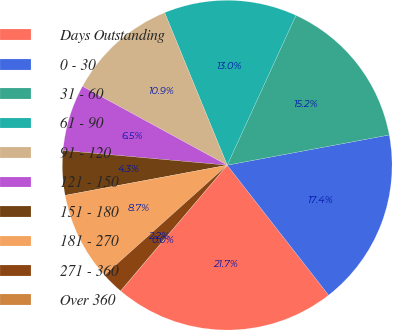Convert chart to OTSL. <chart><loc_0><loc_0><loc_500><loc_500><pie_chart><fcel>Days Outstanding<fcel>0 - 30<fcel>31 - 60<fcel>61 - 90<fcel>91 - 120<fcel>121 - 150<fcel>151 - 180<fcel>181 - 270<fcel>271 - 360<fcel>Over 360<nl><fcel>21.74%<fcel>17.39%<fcel>15.22%<fcel>13.04%<fcel>10.87%<fcel>6.52%<fcel>4.35%<fcel>8.7%<fcel>2.18%<fcel>0.0%<nl></chart> 